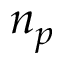<formula> <loc_0><loc_0><loc_500><loc_500>n _ { p }</formula> 